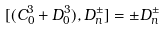<formula> <loc_0><loc_0><loc_500><loc_500>[ ( C _ { 0 } ^ { 3 } + D _ { 0 } ^ { 3 } ) , D _ { n } ^ { \pm } ] = \pm D _ { n } ^ { \pm }</formula> 